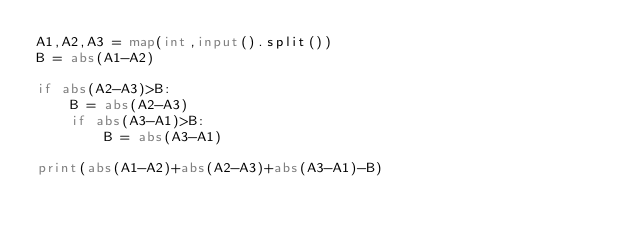Convert code to text. <code><loc_0><loc_0><loc_500><loc_500><_Python_>A1,A2,A3 = map(int,input().split())
B = abs(A1-A2)

if abs(A2-A3)>B:
    B = abs(A2-A3)
    if abs(A3-A1)>B:
        B = abs(A3-A1)

print(abs(A1-A2)+abs(A2-A3)+abs(A3-A1)-B)</code> 